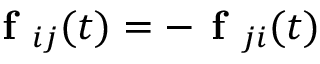Convert formula to latex. <formula><loc_0><loc_0><loc_500><loc_500>f _ { i j } ( t ) = - f _ { j i } ( t )</formula> 